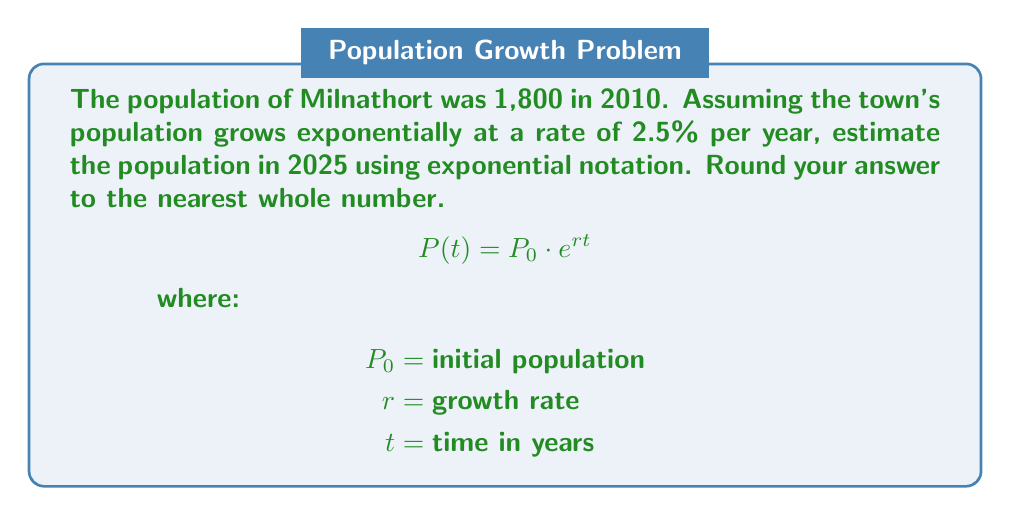What is the answer to this math problem? Let's approach this step-by-step:

1) The exponential growth formula is:
   $A = P(1 + r)^t$
   Where:
   $A$ = Final amount
   $P$ = Initial population
   $r$ = Growth rate (as a decimal)
   $t$ = Time in years

2) We have:
   $P = 1,800$ (initial population in 2010)
   $r = 0.025$ (2.5% written as a decimal)
   $t = 15$ (number of years from 2010 to 2025)

3) Plugging these values into the formula:
   $A = 1,800(1 + 0.025)^{15}$

4) Simplify inside the parentheses:
   $A = 1,800(1.025)^{15}$

5) Now, we can use the properties of exponents to rewrite this in scientific notation:
   $A = 1,800 \times 10^{\log_{10}(1.025^{15})}$

6) Simplify the exponent:
   $A = 1,800 \times 10^{15 \log_{10}(1.025)}$

7) Using a calculator or computer:
   $A = 1,800 \times 10^{0.16442...}$

8) Evaluate:
   $A = 1,800 \times 1.4613...$
   $A = 2,630.34...$

9) Rounding to the nearest whole number:
   $A \approx 2,630$
Answer: 2,630 